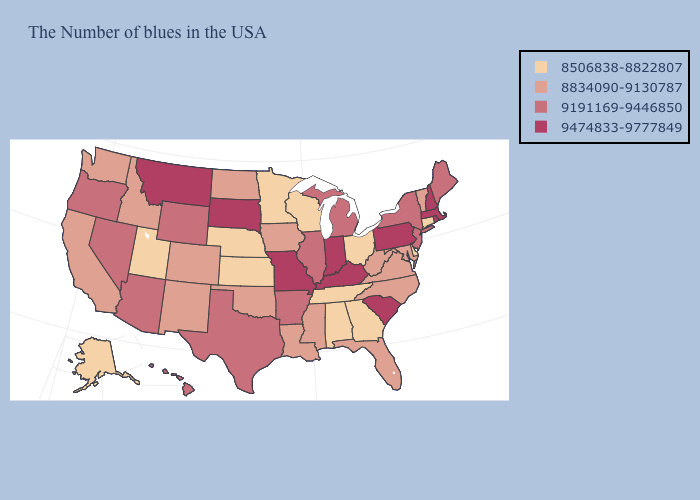Which states have the lowest value in the USA?
Write a very short answer. Connecticut, Delaware, Ohio, Georgia, Alabama, Tennessee, Wisconsin, Minnesota, Kansas, Nebraska, Utah, Alaska. What is the value of Wyoming?
Answer briefly. 9191169-9446850. What is the highest value in the USA?
Quick response, please. 9474833-9777849. Does the first symbol in the legend represent the smallest category?
Answer briefly. Yes. Among the states that border Virginia , does West Virginia have the highest value?
Be succinct. No. Does the first symbol in the legend represent the smallest category?
Answer briefly. Yes. Does Nebraska have the lowest value in the MidWest?
Keep it brief. Yes. What is the lowest value in states that border Oregon?
Quick response, please. 8834090-9130787. Which states have the lowest value in the USA?
Answer briefly. Connecticut, Delaware, Ohio, Georgia, Alabama, Tennessee, Wisconsin, Minnesota, Kansas, Nebraska, Utah, Alaska. What is the value of New York?
Keep it brief. 9191169-9446850. What is the value of North Carolina?
Be succinct. 8834090-9130787. Does Delaware have the same value as Ohio?
Quick response, please. Yes. What is the lowest value in the USA?
Give a very brief answer. 8506838-8822807. Which states have the lowest value in the USA?
Keep it brief. Connecticut, Delaware, Ohio, Georgia, Alabama, Tennessee, Wisconsin, Minnesota, Kansas, Nebraska, Utah, Alaska. Does Wisconsin have a higher value than Nebraska?
Be succinct. No. 